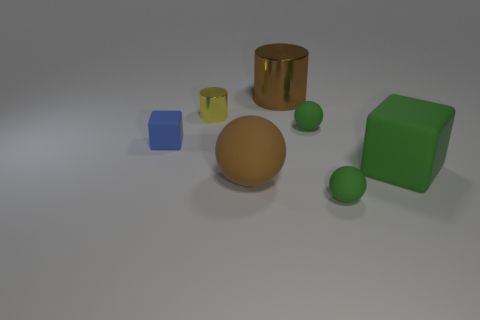The object that is the same color as the large shiny cylinder is what size?
Offer a terse response. Large. How many things are either rubber spheres on the right side of the big metal object or big brown objects right of the brown matte thing?
Provide a succinct answer. 3. Is the number of brown cylinders greater than the number of large gray rubber objects?
Ensure brevity in your answer.  Yes. There is a block that is on the left side of the large green rubber object; what color is it?
Your answer should be compact. Blue. Do the yellow thing and the large shiny thing have the same shape?
Your answer should be compact. Yes. There is a rubber object that is behind the green matte block and right of the tiny metallic object; what is its color?
Offer a terse response. Green. Is the size of the yellow cylinder on the right side of the blue cube the same as the block that is left of the brown shiny cylinder?
Give a very brief answer. Yes. How many things are either metallic cylinders behind the tiny yellow shiny cylinder or small green matte balls?
Your response must be concise. 3. What material is the tiny cube?
Offer a terse response. Rubber. Do the brown shiny cylinder and the yellow metallic cylinder have the same size?
Provide a succinct answer. No. 